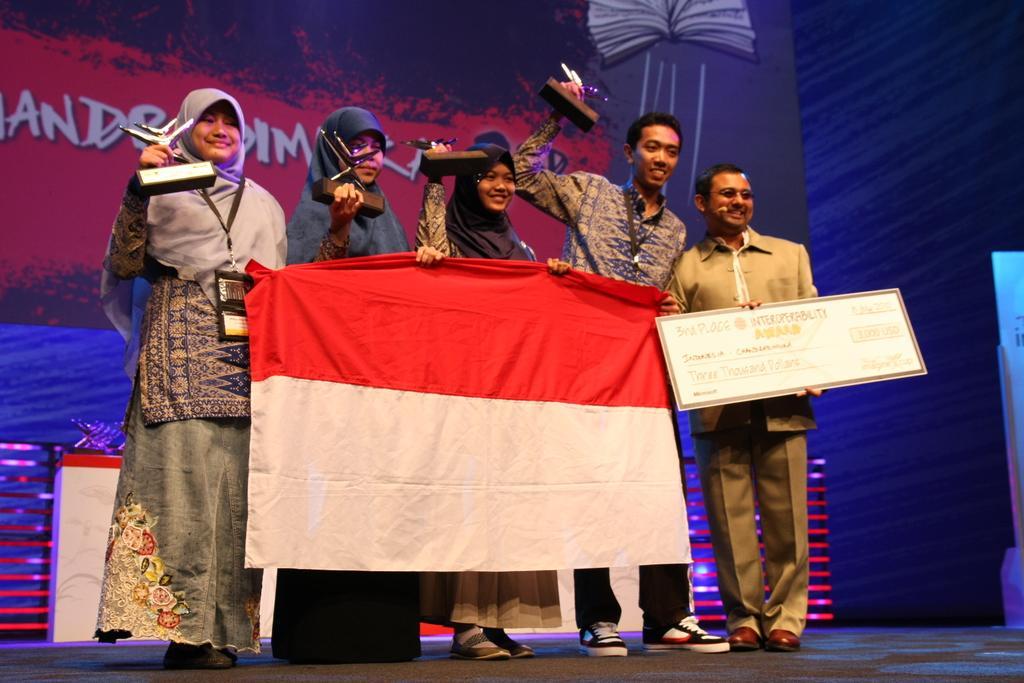Could you give a brief overview of what you see in this image? In this image I can see group of people standing and they are holding a cloth and the cloth is in white and red color. I can also see a person holding a board which is in white color, background I can see a banner in blue, red and black color. 